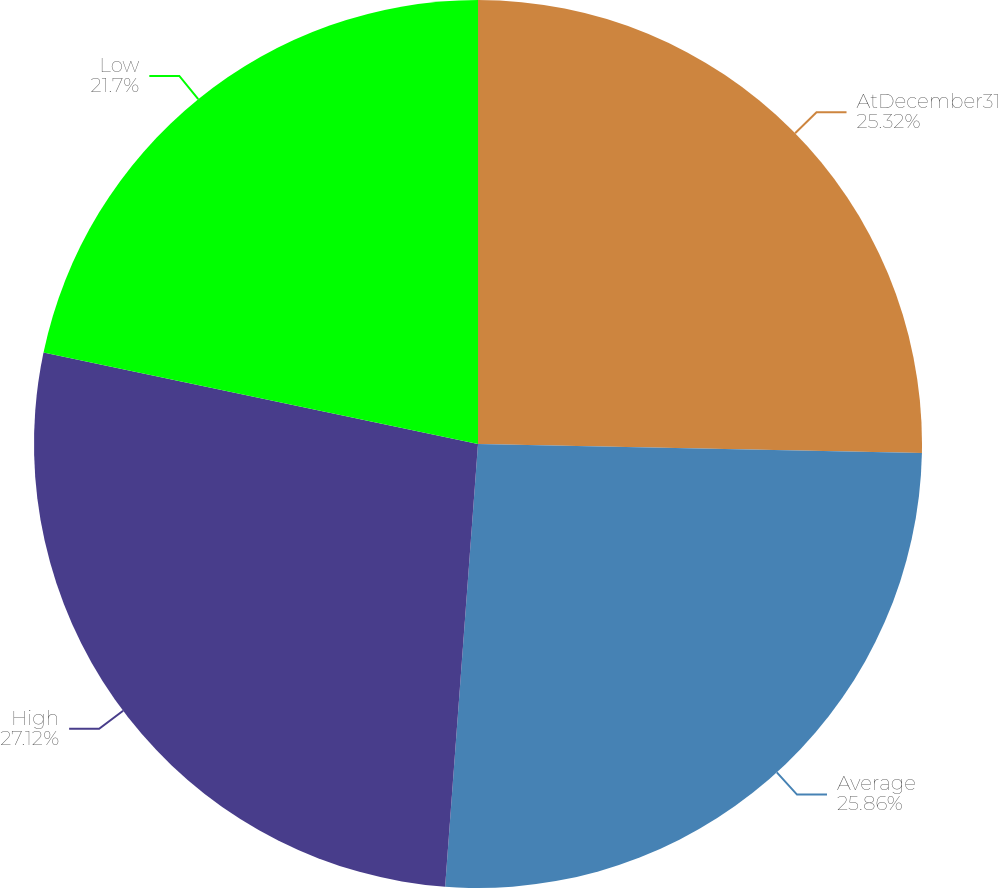Convert chart to OTSL. <chart><loc_0><loc_0><loc_500><loc_500><pie_chart><fcel>AtDecember31<fcel>Average<fcel>High<fcel>Low<nl><fcel>25.32%<fcel>25.86%<fcel>27.12%<fcel>21.7%<nl></chart> 